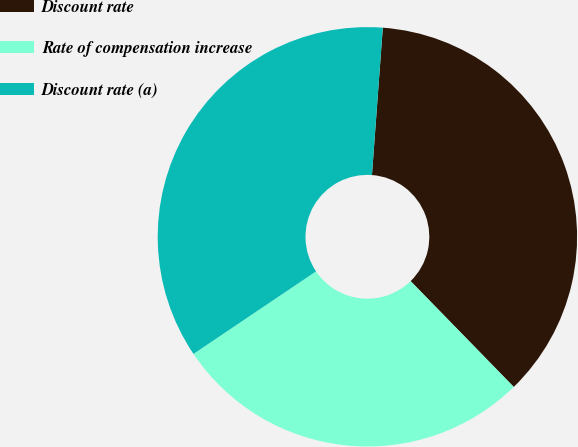<chart> <loc_0><loc_0><loc_500><loc_500><pie_chart><fcel>Discount rate<fcel>Rate of compensation increase<fcel>Discount rate (a)<nl><fcel>36.53%<fcel>27.86%<fcel>35.6%<nl></chart> 